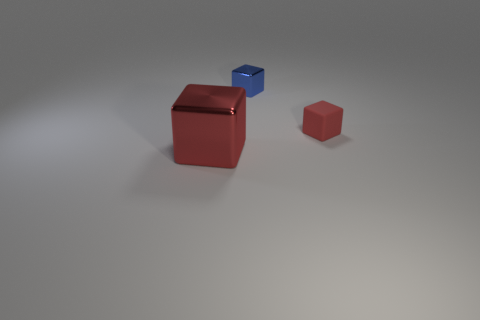Is the shape of the red thing right of the big red metal object the same as the red object that is on the left side of the tiny blue cube?
Keep it short and to the point. Yes. Does the matte block have the same size as the red thing that is to the left of the tiny blue object?
Your response must be concise. No. How many other objects are there of the same material as the small blue object?
Offer a terse response. 1. Is there any other thing that is the same shape as the large red shiny object?
Ensure brevity in your answer.  Yes. There is a metallic block that is to the right of the red thing on the left side of the small object on the left side of the rubber thing; what is its color?
Ensure brevity in your answer.  Blue. What shape is the thing that is to the left of the small red block and in front of the tiny blue cube?
Your answer should be very brief. Cube. Is there anything else that is the same size as the red shiny block?
Give a very brief answer. No. There is a metal cube that is behind the red thing to the left of the small red matte object; what is its color?
Your answer should be compact. Blue. There is a metallic thing that is in front of the metal object that is right of the red block to the left of the red rubber cube; what is its shape?
Your answer should be very brief. Cube. How big is the block that is both on the left side of the small red thing and in front of the tiny blue metal thing?
Your answer should be very brief. Large. 